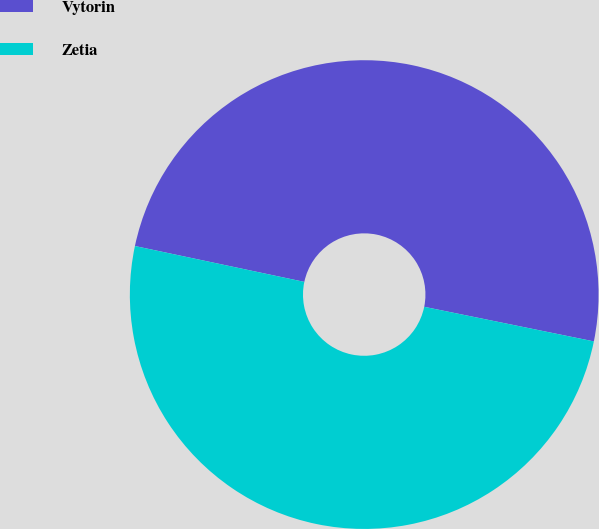<chart> <loc_0><loc_0><loc_500><loc_500><pie_chart><fcel>Vytorin<fcel>Zetia<nl><fcel>49.88%<fcel>50.12%<nl></chart> 